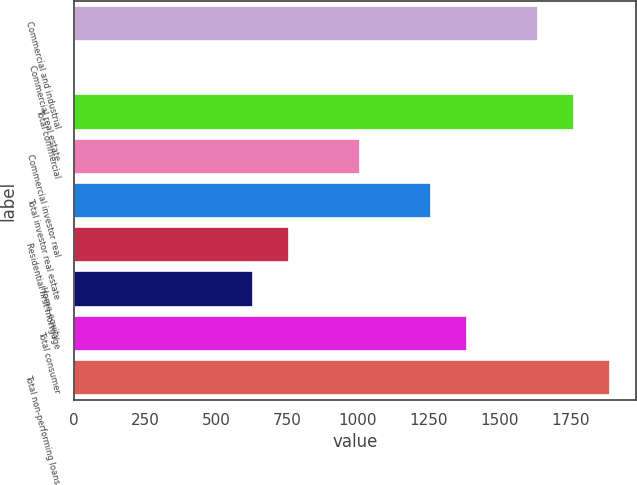<chart> <loc_0><loc_0><loc_500><loc_500><bar_chart><fcel>Commercial and industrial<fcel>Commercial real estate<fcel>Total commercial<fcel>Commercial investor real<fcel>Total investor real estate<fcel>Residential first mortgage<fcel>Home equity<fcel>Total consumer<fcel>Total non-performing loans<nl><fcel>1637.1<fcel>3<fcel>1762.8<fcel>1008.6<fcel>1260<fcel>757.2<fcel>631.5<fcel>1385.7<fcel>1888.5<nl></chart> 